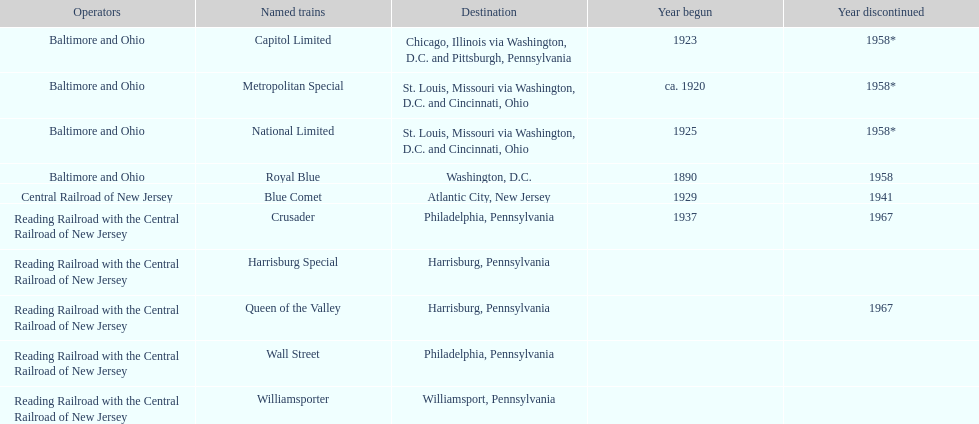What is the sum of all years that have initiated? 6. 